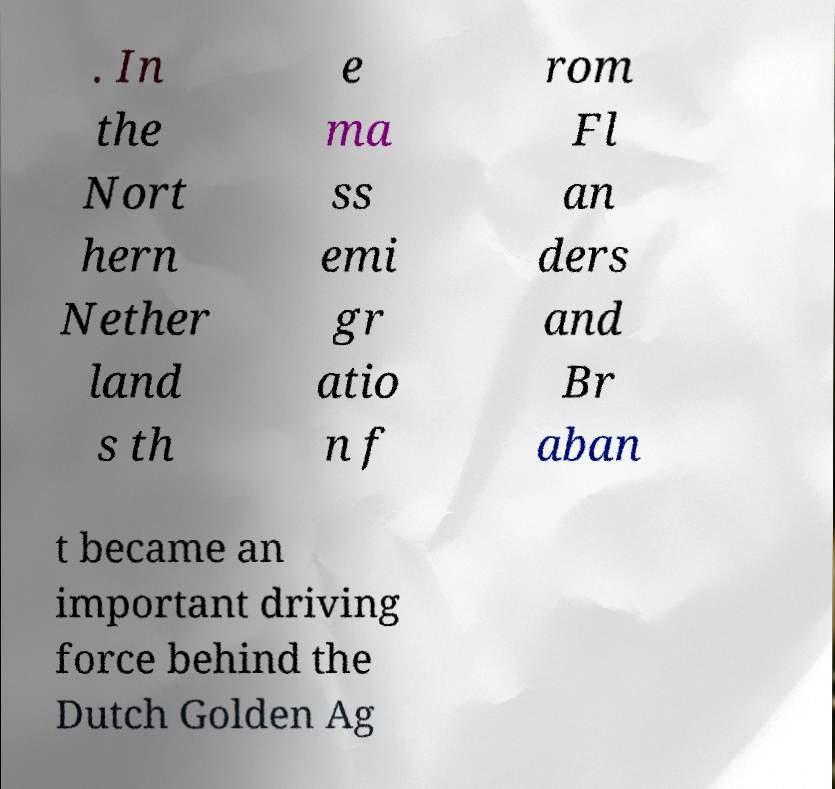Can you read and provide the text displayed in the image?This photo seems to have some interesting text. Can you extract and type it out for me? . In the Nort hern Nether land s th e ma ss emi gr atio n f rom Fl an ders and Br aban t became an important driving force behind the Dutch Golden Ag 